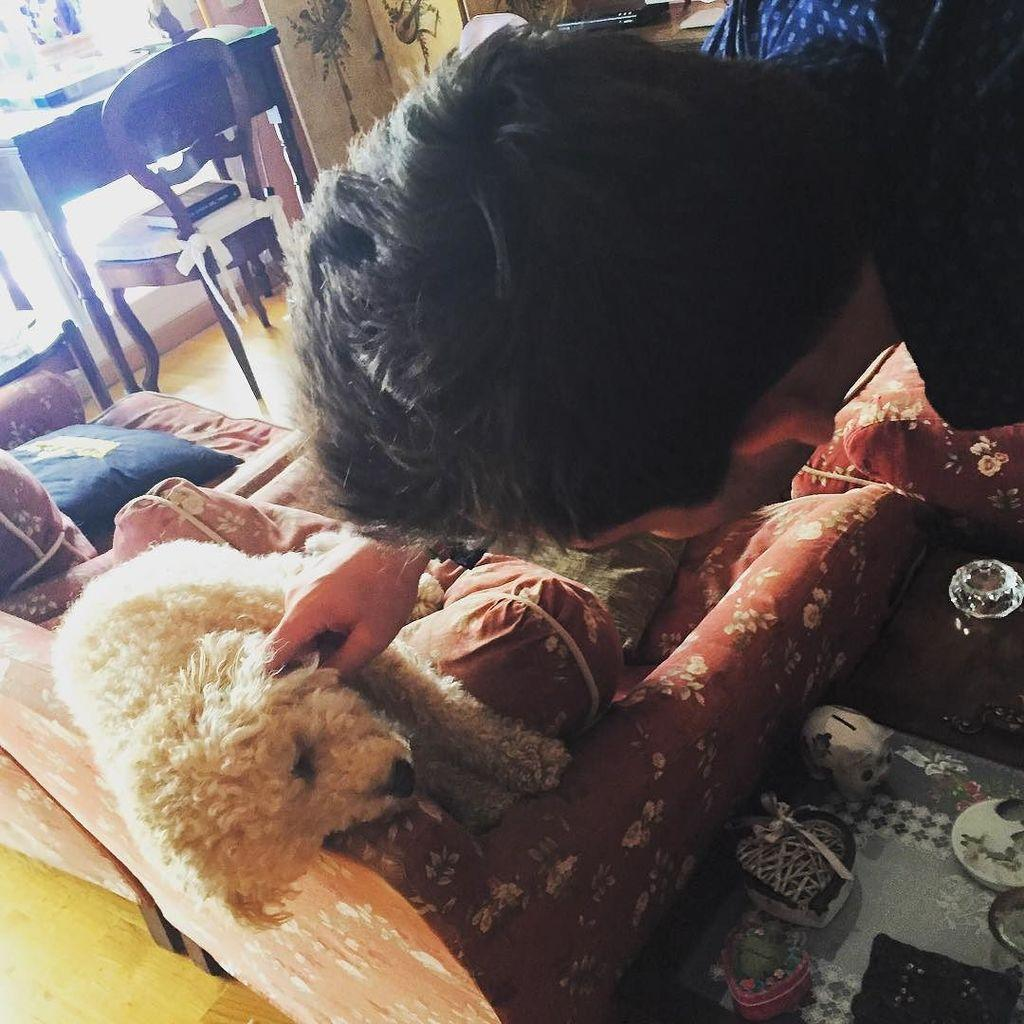What is the primary subject in the image? There is a person standing in the image. Where is the person standing? The person is standing on the floor. What other living creature is present in the image? There is a dog in the image. What is the dog doing in the image? The dog is lying on a sofa. What type of furniture is present in the image? There is a table and a chair in the image. What type of soft furnishings are present in the image? There are pillows in the image. What is on the floor in the image? There are objects on the carpet in the image. What type of pies is the grandmother baking in the image? There is no grandmother or pies present in the image. 